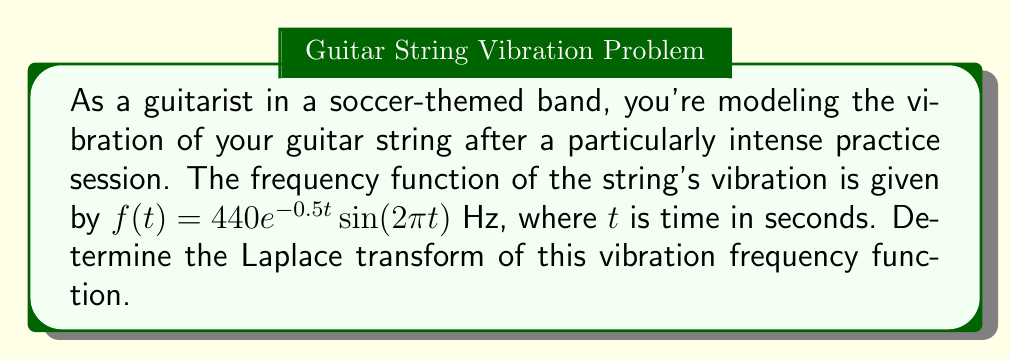Can you solve this math problem? To solve this problem, we'll use the Laplace transform definition and properties. Let's break it down step-by-step:

1) The Laplace transform of a function $f(t)$ is defined as:

   $$\mathcal{L}\{f(t)\} = F(s) = \int_0^\infty e^{-st}f(t)dt$$

2) Our function is $f(t) = 440e^{-0.5t}\sin(2\pi t)$. We can rewrite this as:

   $$f(t) = 440 \cdot e^{-0.5t} \cdot \sin(2\pi t)$$

3) We can use the property of Laplace transform for exponential functions:

   $$\mathcal{L}\{e^{at}f(t)\} = F(s-a)$$

   In our case, $a = -0.5$, so we'll be using $F(s+0.5)$.

4) We also know the Laplace transform of sine function:

   $$\mathcal{L}\{\sin(\omega t)\} = \frac{\omega}{s^2 + \omega^2}$$

   Here, $\omega = 2\pi$.

5) Combining these properties:

   $$\mathcal{L}\{440e^{-0.5t}\sin(2\pi t)\} = 440 \cdot F(s+0.5)$$

   Where $F(s) = \frac{2\pi}{s^2 + (2\pi)^2}$

6) Substituting $s$ with $s+0.5$:

   $$F(s) = 440 \cdot \frac{2\pi}{(s+0.5)^2 + (2\pi)^2}$$

7) Simplifying:

   $$F(s) = \frac{880\pi}{s^2 + s + 4\pi^2 + 0.25}$$

This is the Laplace transform of the given vibration frequency function.
Answer: $$F(s) = \frac{880\pi}{s^2 + s + 4\pi^2 + 0.25}$$ 